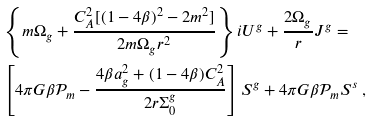<formula> <loc_0><loc_0><loc_500><loc_500>& \left \{ m \Omega _ { g } + \frac { C _ { A } ^ { 2 } [ ( 1 - 4 \beta ) ^ { 2 } - 2 m ^ { 2 } ] } { 2 m \Omega _ { g } r ^ { 2 } } \right \} i U ^ { g } + \frac { 2 \Omega _ { g } } { r } J ^ { g } = \\ & \left [ 4 \pi G \beta \mathcal { P } _ { m } - \frac { 4 \beta a _ { g } ^ { 2 } + ( 1 - 4 \beta ) C _ { A } ^ { 2 } } { 2 r \Sigma _ { 0 } ^ { g } } \right ] S ^ { g } + 4 \pi G \beta \mathcal { P } _ { m } S ^ { s } \ ,</formula> 